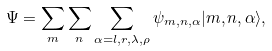Convert formula to latex. <formula><loc_0><loc_0><loc_500><loc_500>\Psi = \sum _ { m } \sum _ { n } \sum _ { \alpha = l , r , \lambda , \rho } \psi _ { m , n , \alpha } | m , n , \alpha \rangle ,</formula> 